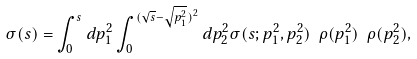Convert formula to latex. <formula><loc_0><loc_0><loc_500><loc_500>\sigma ( s ) = \int _ { 0 } ^ { s } d p _ { 1 } ^ { 2 } \int _ { 0 } ^ { ( \sqrt { s } - \sqrt { p _ { 1 } ^ { 2 } } ) ^ { 2 } } d p _ { 2 } ^ { 2 } \sigma ( s ; p _ { 1 } ^ { 2 } , p _ { 2 } ^ { 2 } ) \ \rho ( p _ { 1 } ^ { 2 } ) \ \rho ( p _ { 2 } ^ { 2 } ) ,</formula> 